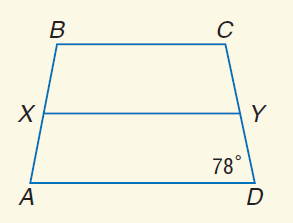Question: For isosceles trapezoid A B C D, X and Y are midpoints of the legs. Find m \angle X B C if m \angle A D Y = 78.
Choices:
A. 39
B. 51
C. 78
D. 102
Answer with the letter. Answer: D 